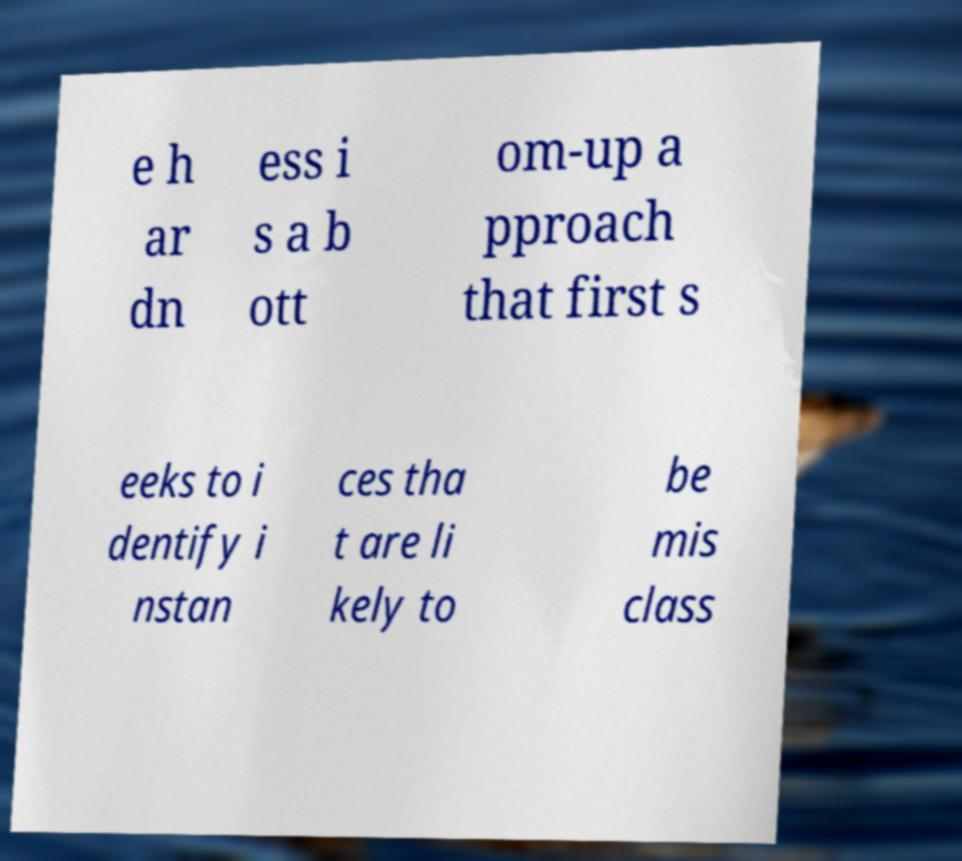Can you read and provide the text displayed in the image?This photo seems to have some interesting text. Can you extract and type it out for me? e h ar dn ess i s a b ott om-up a pproach that first s eeks to i dentify i nstan ces tha t are li kely to be mis class 